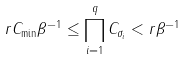<formula> <loc_0><loc_0><loc_500><loc_500>r C _ { \min } { \beta } ^ { - 1 } & \leq \prod _ { i = 1 } ^ { q } C _ { \sigma _ { i } } < r { \beta } ^ { - 1 }</formula> 